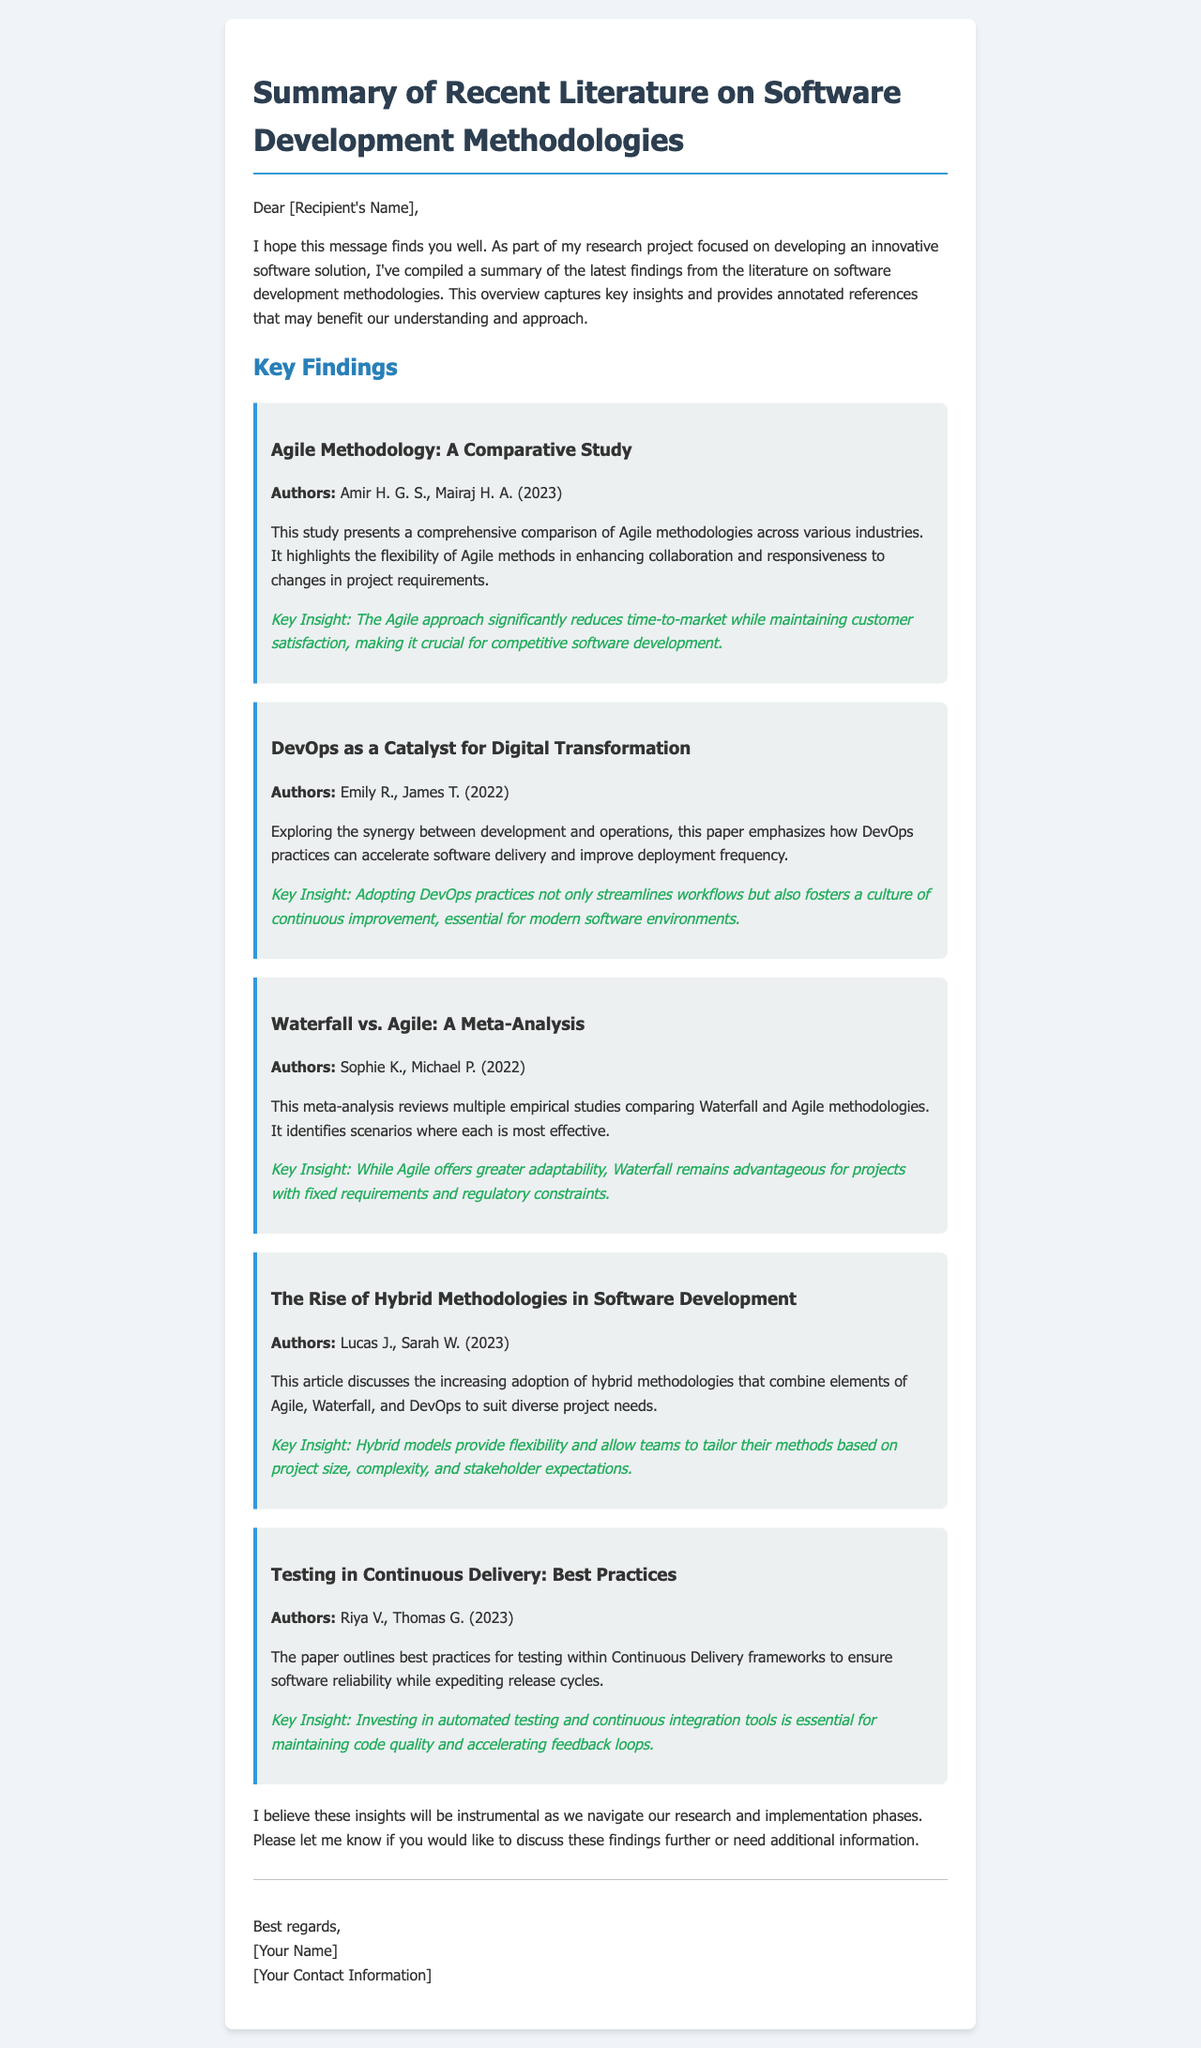What is the title of the document? The title is the main heading of the email summarizing the findings.
Answer: Summary of Recent Literature on Software Development Methodologies Who are the authors of the Agile methodology study? The names of the authors are mentioned under the Agile finding.
Answer: Amir H. G. S., Mairaj H. A In which year was the DevOps study published? The publication year is stated in the finding about DevOps.
Answer: 2022 What key insight is provided regarding Agile methodologies? The key insights summarize the main findings in each section.
Answer: The Agile approach significantly reduces time-to-market while maintaining customer satisfaction Which methodology remains advantageous for projects with fixed requirements? The comparison between methodologies highlights the effectiveness of Waterfall in certain scenarios.
Answer: Waterfall What is one best practice mentioned for testing in Continuous Delivery? The paper outlines practices related to quality assurance in software development.
Answer: Investing in automated testing and continuous integration tools What key insight does the meta-analysis provide about Agile and Waterfall? The meta-analysis compares the adaptability of Agile and the fixed nature of Waterfall.
Answer: While Agile offers greater adaptability, Waterfall remains advantageous for projects with fixed requirements and regulatory constraints What is a major benefit of adopting DevOps practices? The findings about DevOps emphasize its impact on software delivery processes.
Answer: Fosters a culture of continuous improvement What is the last finding discussed in the email? The last section of findings is presented in chronological order, highlighting various studies.
Answer: Testing in Continuous Delivery: Best Practices 